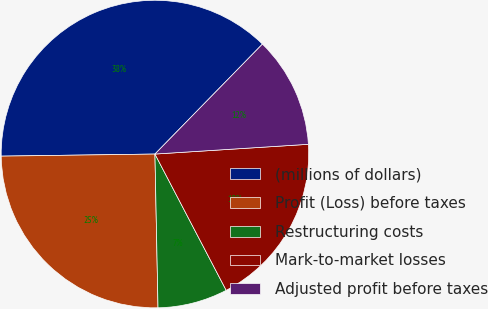Convert chart. <chart><loc_0><loc_0><loc_500><loc_500><pie_chart><fcel>(millions of dollars)<fcel>Profit (Loss) before taxes<fcel>Restructuring costs<fcel>Mark-to-market losses<fcel>Adjusted profit before taxes<nl><fcel>37.53%<fcel>25.1%<fcel>7.35%<fcel>18.34%<fcel>11.67%<nl></chart> 